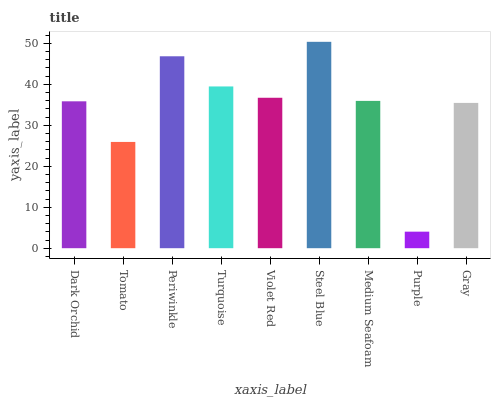Is Purple the minimum?
Answer yes or no. Yes. Is Steel Blue the maximum?
Answer yes or no. Yes. Is Tomato the minimum?
Answer yes or no. No. Is Tomato the maximum?
Answer yes or no. No. Is Dark Orchid greater than Tomato?
Answer yes or no. Yes. Is Tomato less than Dark Orchid?
Answer yes or no. Yes. Is Tomato greater than Dark Orchid?
Answer yes or no. No. Is Dark Orchid less than Tomato?
Answer yes or no. No. Is Medium Seafoam the high median?
Answer yes or no. Yes. Is Medium Seafoam the low median?
Answer yes or no. Yes. Is Periwinkle the high median?
Answer yes or no. No. Is Turquoise the low median?
Answer yes or no. No. 